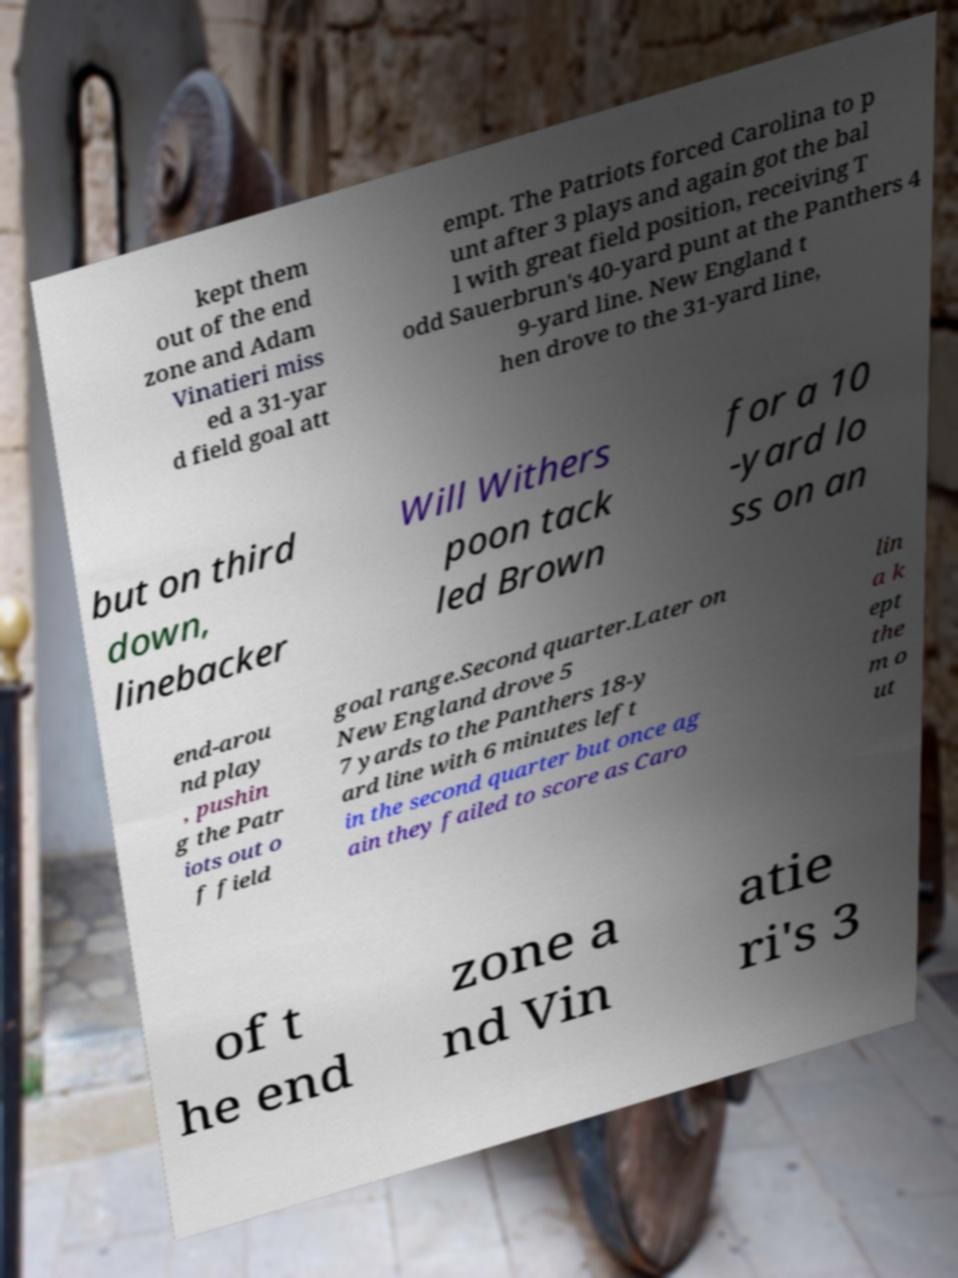Please read and relay the text visible in this image. What does it say? kept them out of the end zone and Adam Vinatieri miss ed a 31-yar d field goal att empt. The Patriots forced Carolina to p unt after 3 plays and again got the bal l with great field position, receiving T odd Sauerbrun's 40-yard punt at the Panthers 4 9-yard line. New England t hen drove to the 31-yard line, but on third down, linebacker Will Withers poon tack led Brown for a 10 -yard lo ss on an end-arou nd play , pushin g the Patr iots out o f field goal range.Second quarter.Later on New England drove 5 7 yards to the Panthers 18-y ard line with 6 minutes left in the second quarter but once ag ain they failed to score as Caro lin a k ept the m o ut of t he end zone a nd Vin atie ri's 3 